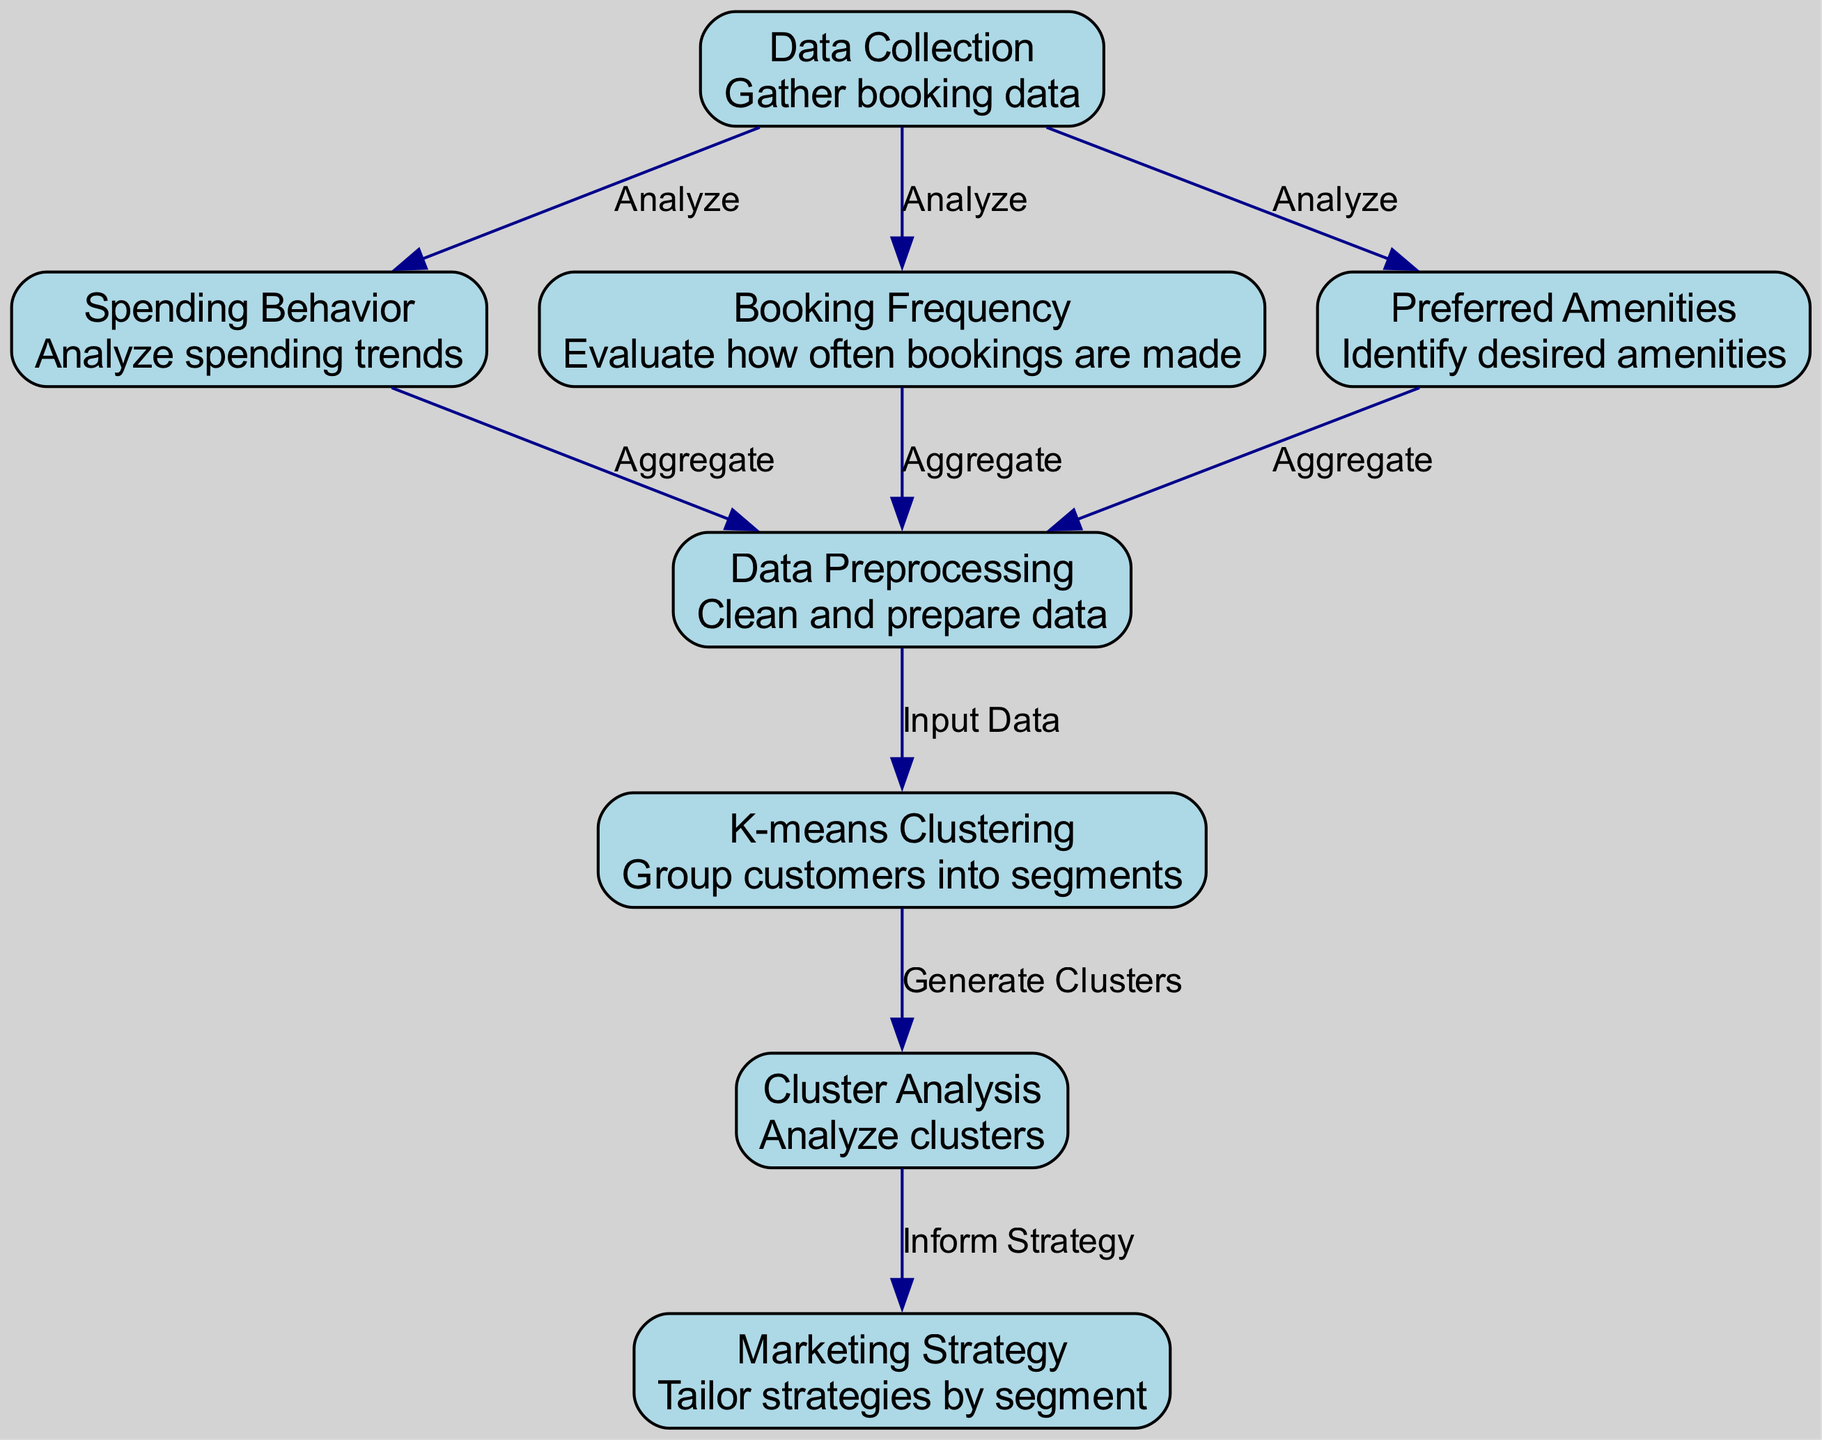What is the total number of nodes in the diagram? The diagram lists eight individual nodes, each representing a process in the customer segmentation workflow. By counting each listed node, the total is confirmed to be eight.
Answer: Eight How many edges connect to the "Data Preprocessing" node? The "Data Preprocessing" node is connected by three edges: one each from "Spending Behavior," "Booking Frequency," and "Preferred Amenities." Thus, there are three connections in total.
Answer: Three Which node comes after "K-means Clustering"? The direct successor node after "K-means Clustering" is "Cluster Analysis," as indicated by the edge that leads from "K-means Clustering" to "Cluster Analysis."
Answer: Cluster Analysis From which node does the "Market Strategy" node receive input indirectly? The "Market Strategy" node is informed indirectly through the "Cluster Analysis," which is influenced by "K-means Clustering." Therefore, the input comes from "Cluster Analysis" by analyzing the clusters first.
Answer: Cluster Analysis What is the purpose of the node labeled "Spending Behavior"? The "Spending Behavior" node analyzes spending trends derived from the collected booking data, which helps in understanding the financial patterns of potential customers.
Answer: Analyze spending trends How does the process flow from "Data Collection" to "Market Strategy"? The flow begins at "Data Collection," connecting to three nodes: "Spending Behavior," "Booking Frequency," and "Preferred Amenities." Each of these nodes aggregates data into "Data Preprocessing," which then inputs into "K-means Clustering." Finally, "Cluster Analysis" generates insights that inform the "Market Strategy."
Answer: Through seven nodes in sequence What describes the relationship between "Cluster Analysis" and "Market Strategy"? "Cluster Analysis" informs the "Market Strategy" as it provides insights derived from analyzing the customer segments generated during the clustering stage. This is a key step in tailoring strategies based on segmented data.
Answer: Inform Strategy Which three nodes are analyzed by "Data Collection"? "Data Collection" analyzes "Spending Behavior," "Booking Frequency," and "Preferred Amenities." These three aspects are foundational for understanding customer engagement.
Answer: Spending Behavior, Booking Frequency, Preferred Amenities What technique is used to group customers into segments? The technique used for grouping customers is "K-means Clustering," which is specifically designed to identify distinct customer segments based on various input features like spending behavior and booking frequency.
Answer: K-means Clustering 